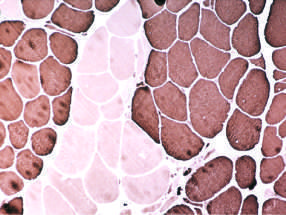under what conditions do clusters of fibers appear that all share the same fiber type?
Answer the question using a single word or phrase. With ongoing denervation and reinnervation 